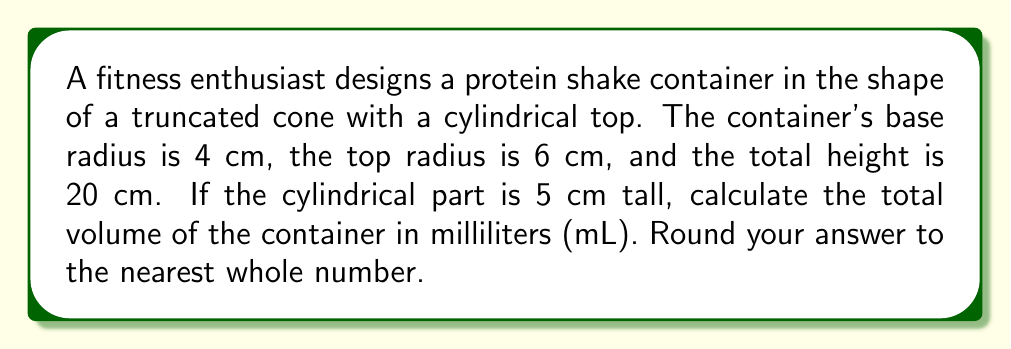Could you help me with this problem? Let's approach this step-by-step:

1) The container consists of two parts: a truncated cone and a cylinder on top.

2) For the truncated cone:
   - Base radius $r_1 = 4$ cm
   - Top radius $r_2 = 6$ cm
   - Height $h_1 = 20 - 5 = 15$ cm (total height minus cylinder height)

3) The volume of a truncated cone is given by:
   $$V_1 = \frac{1}{3}\pi h_1(r_1^2 + r_2^2 + r_1r_2)$$

4) Substituting the values:
   $$V_1 = \frac{1}{3}\pi \cdot 15(4^2 + 6^2 + 4 \cdot 6)$$
   $$V_1 = 5\pi(16 + 36 + 24) = 5\pi \cdot 76 = 380\pi \text{ cm}^3$$

5) For the cylindrical top:
   - Radius $r = 6$ cm
   - Height $h_2 = 5$ cm

6) The volume of a cylinder is given by:
   $$V_2 = \pi r^2 h_2$$

7) Substituting the values:
   $$V_2 = \pi \cdot 6^2 \cdot 5 = 180\pi \text{ cm}^3$$

8) The total volume is the sum of both parts:
   $$V_{\text{total}} = V_1 + V_2 = 380\pi + 180\pi = 560\pi \text{ cm}^3$$

9) Converting to milliliters (1 cm³ = 1 mL):
   $$V_{\text{total}} = 560\pi \approx 1758.4 \text{ mL}$$

10) Rounding to the nearest whole number:
    $$V_{\text{total}} \approx 1758 \text{ mL}$$
Answer: 1758 mL 